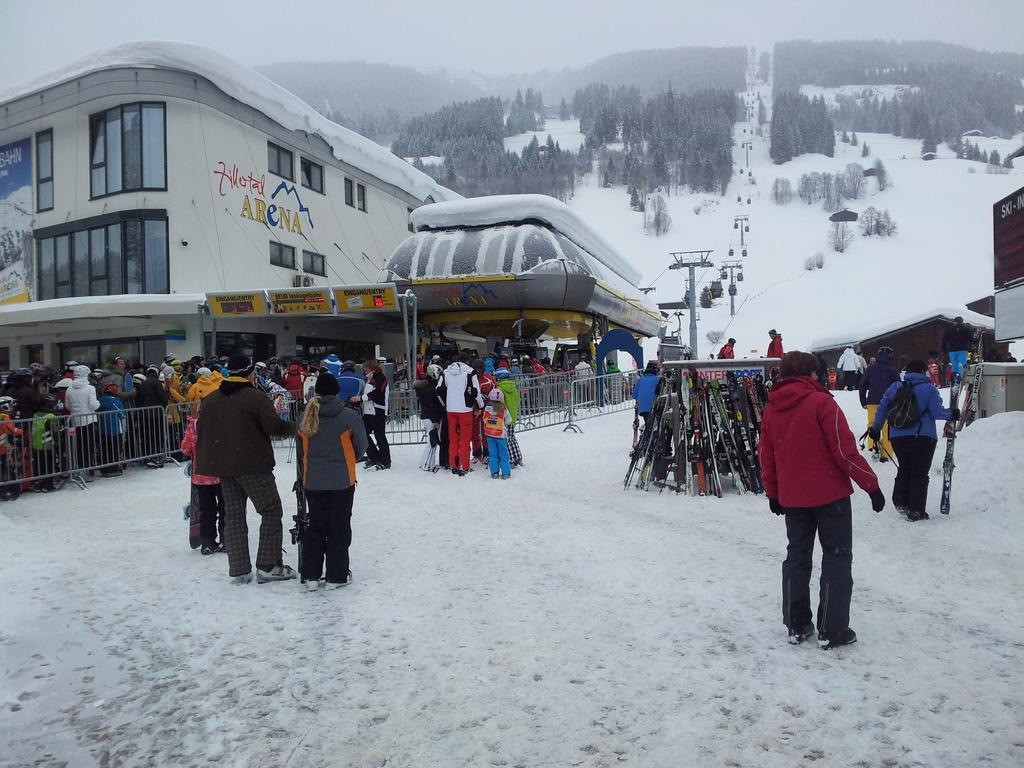Can you describe this image briefly? In this image, there is an outside view. There are group of people wearing clothes and standing in front of the building. There is a ropeway and some trees at the top of the image. 